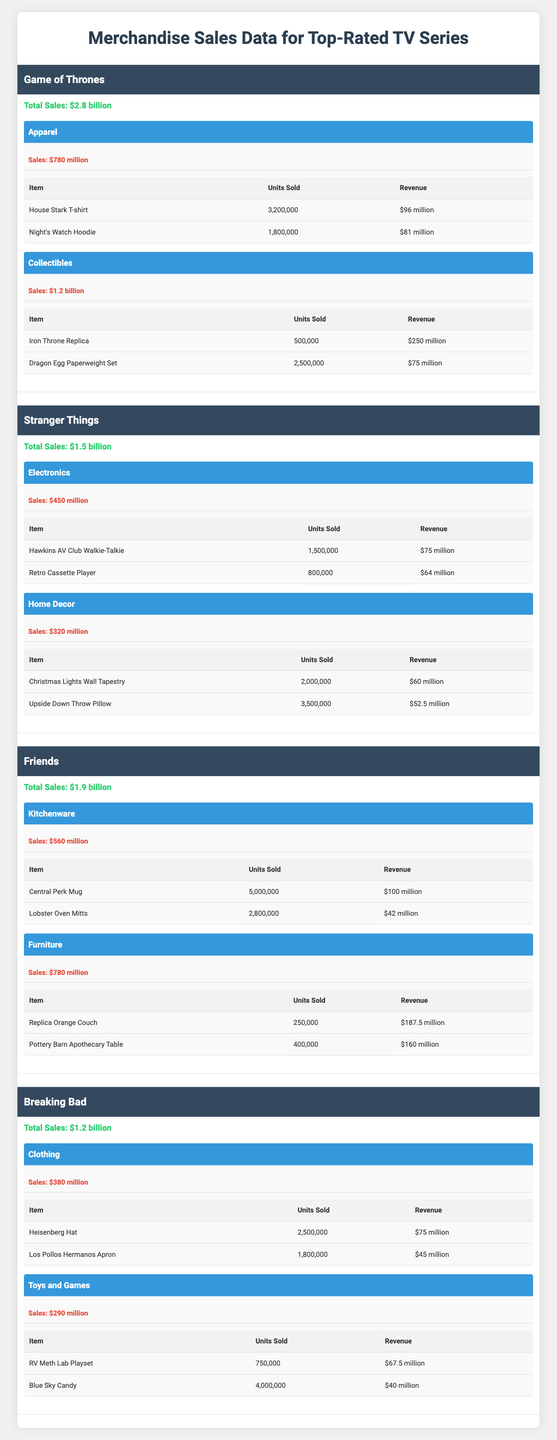What is the total sales amount for "Breaking Bad"? The table shows that "Breaking Bad" has a total sales amount of $1.2 billion listed directly under its series.
Answer: $1.2 billion Which series has the highest sales in the "Collectibles" category? In the table, "Game of Thrones" has a sales figure of $1.2 billion in the "Collectibles" category, which is higher than other series.
Answer: Game of Thrones How many units of the "House Stark T-shirt" were sold? The table indicates that 3,200,000 units of the "House Stark T-shirt" were sold, providing the exact figure under the item's details.
Answer: 3,200,000 What is the combined total sales for the "Apparel" and "Collectibles" categories for "Game of Thrones"? For "Game of Thrones," the total sales in "Apparel" is $780 million and in "Collectibles" is $1.2 billion. Summing these gives $780 million + $1.2 billion = $1.98 billion.
Answer: $1.98 billion What percentage of the total sales for "Friends" comes from the "Furniture" category? "Friends" has total sales of $1.9 billion, with "Furniture" sales at $780 million. The percentage is calculated as ($780 million / $1.9 billion) * 100 ≈ 41.05%.
Answer: Approximately 41.05% Did "Stranger Things" have more sales in "Home Decor" than "Breaking Bad" in "Toys and Games"? "Stranger Things" has $320 million in "Home Decor" and "Breaking Bad" has $290 million in "Toys and Games". Since 320 million is greater than 290 million, the statement is true.
Answer: Yes Which series had the most successful single item in terms of revenue and what was it? In the table, "Iron Throne Replica" under "Game of Thrones" has the highest revenue of $250 million, which is more than any other item listed.
Answer: Iron Throne Replica What is the total revenue from all top items in "Friends"? The top items in "Friends" are the "Central Perk Mug" with $100 million and "Lobster Oven Mitts" with $42 million. The total revenue is $100 million + $42 million = $142 million.
Answer: $142 million Is the total sales amount for "Stranger Things" higher or lower than the combined total of "Apparel" for "Game of Thrones"? "Stranger Things" has total sales of $1.5 billion. The "Apparel" category for "Game of Thrones" totals $780 million. Since $1.5 billion is greater than $780 million, the answer is higher.
Answer: Higher What is the average revenue of the top items in the "Clothing" category of "Breaking Bad"? The total revenue from the top items in "Breaking Bad" under "Clothing" is $75 million for the "Heisenberg Hat" and $45 million for the "Los Pollos Hermanos Apron". Summing gives $120 million for 2 items, so the average is $120 million / 2 = $60 million.
Answer: $60 million 